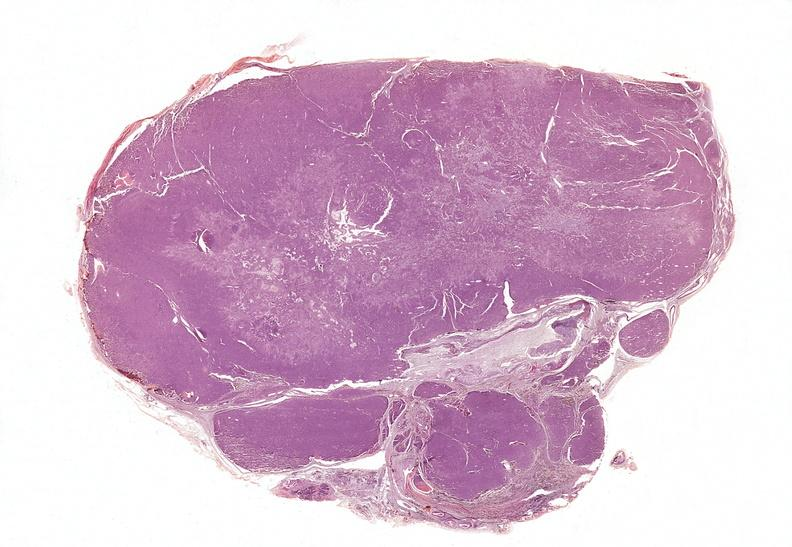s polycystic disease present?
Answer the question using a single word or phrase. No 